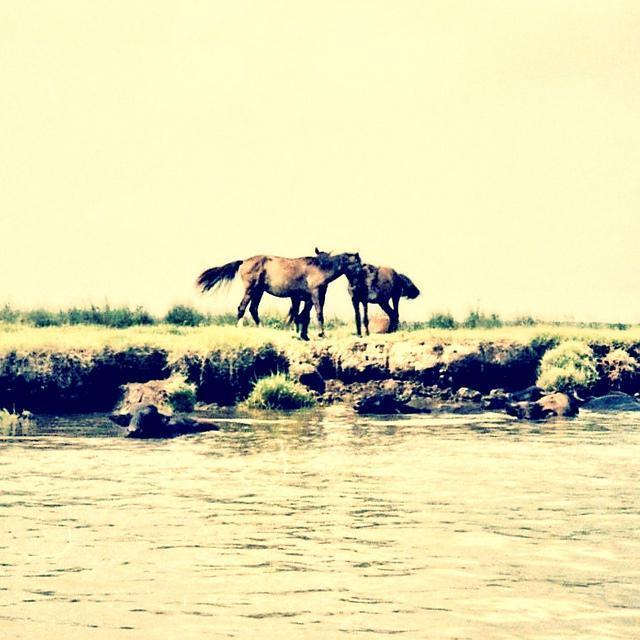How many horses are in the scene?
Give a very brief answer. 2. How many horses are standing in the row?
Give a very brief answer. 2. How many horses are there?
Give a very brief answer. 2. 